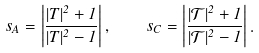Convert formula to latex. <formula><loc_0><loc_0><loc_500><loc_500>s _ { A } = \left | \frac { | T | ^ { 2 } + 1 } { | T | ^ { 2 } - 1 } \right | , \quad s _ { C } = \left | \frac { | \mathcal { T } | ^ { 2 } + 1 } { | \mathcal { T } | ^ { 2 } - 1 } \right | .</formula> 